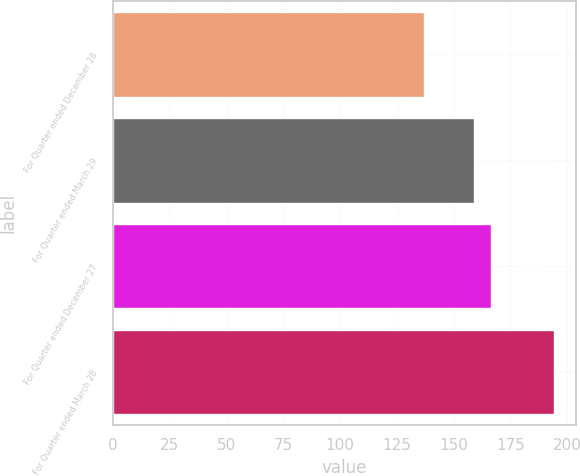Convert chart to OTSL. <chart><loc_0><loc_0><loc_500><loc_500><bar_chart><fcel>For Quarter ended December 28<fcel>For Quarter ended March 29<fcel>For Quarter ended December 27<fcel>For Quarter ended March 28<nl><fcel>136.86<fcel>158.87<fcel>166.61<fcel>194.3<nl></chart> 